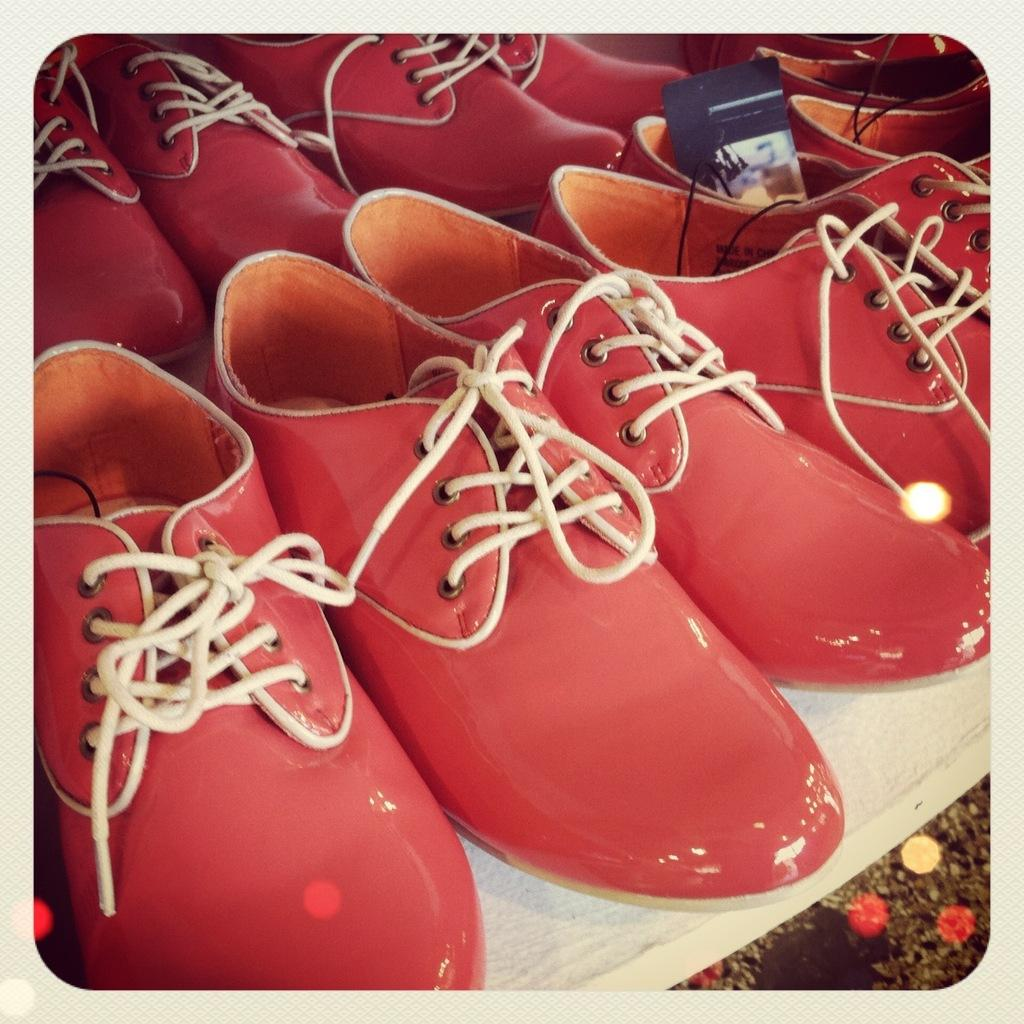What objects are in the image? There are shoes in the image. Where are the shoes located? The shoes are placed on a table. What type of straw is being used to drink the blood in the image? There is no straw or blood present in the image; it only features shoes placed on a table. 